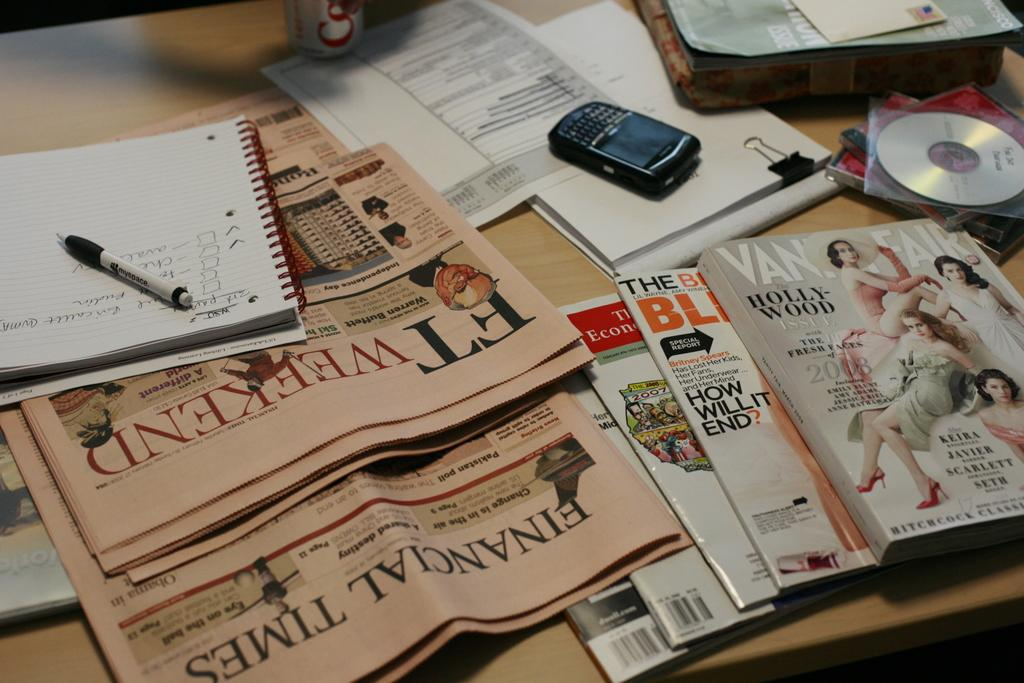<image>
Write a terse but informative summary of the picture. Financial Times and FT weekend newspapers and Hollywood issue magazine. 